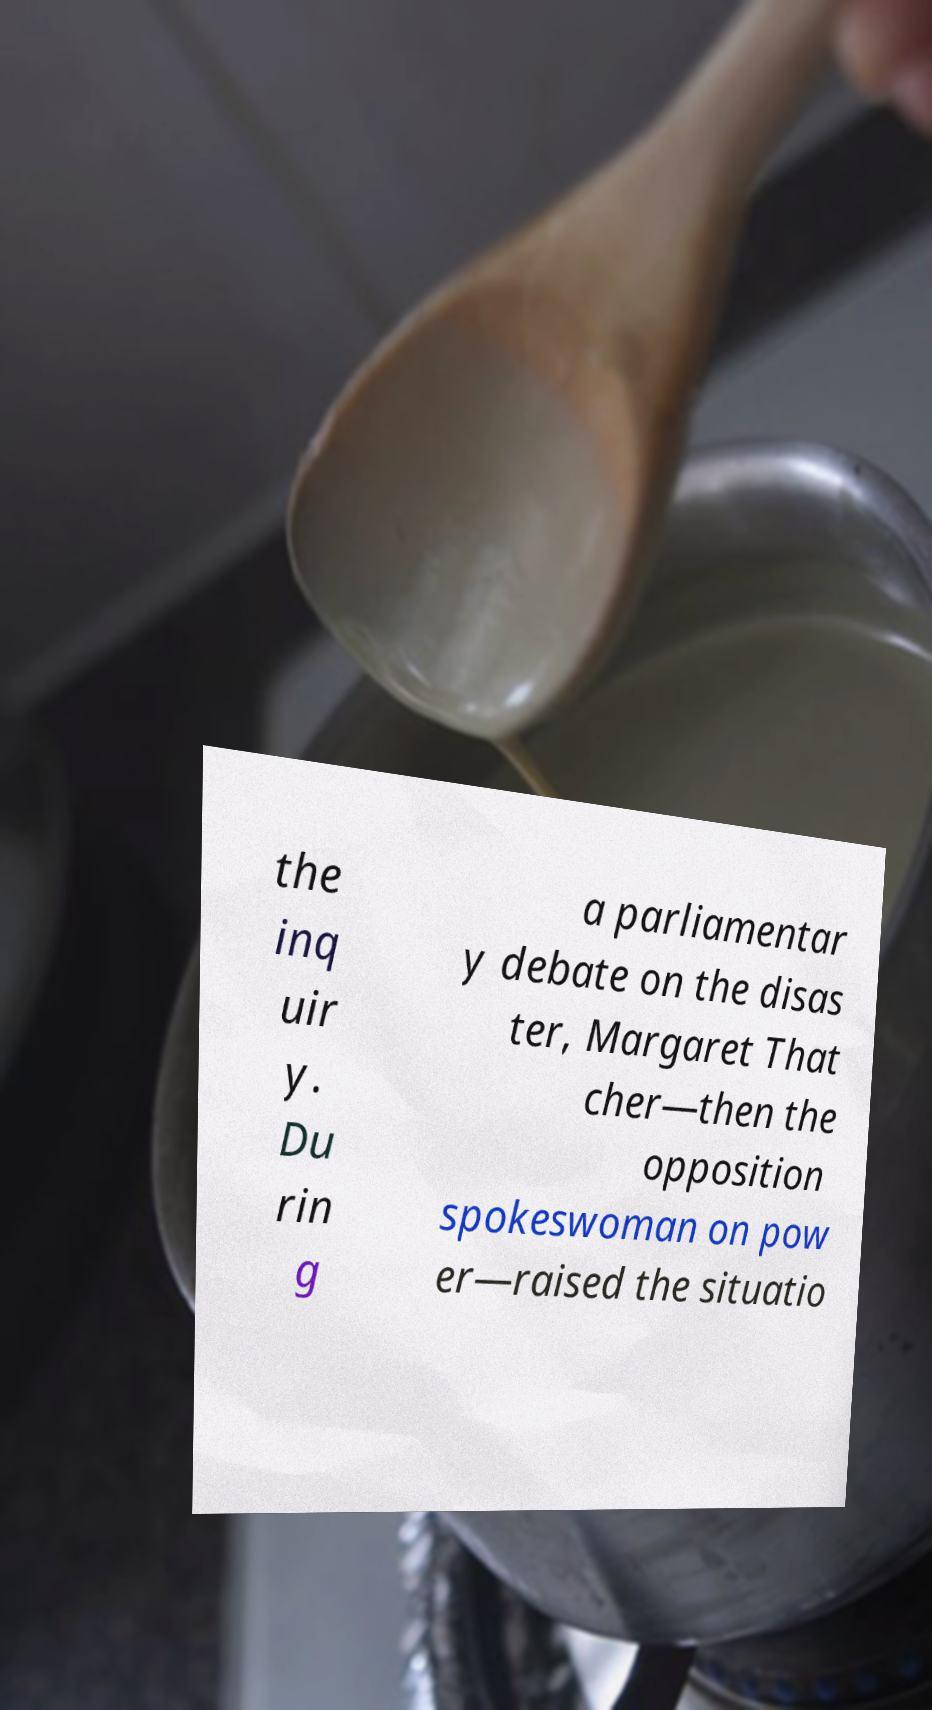Could you assist in decoding the text presented in this image and type it out clearly? the inq uir y. Du rin g a parliamentar y debate on the disas ter, Margaret That cher—then the opposition spokeswoman on pow er—raised the situatio 